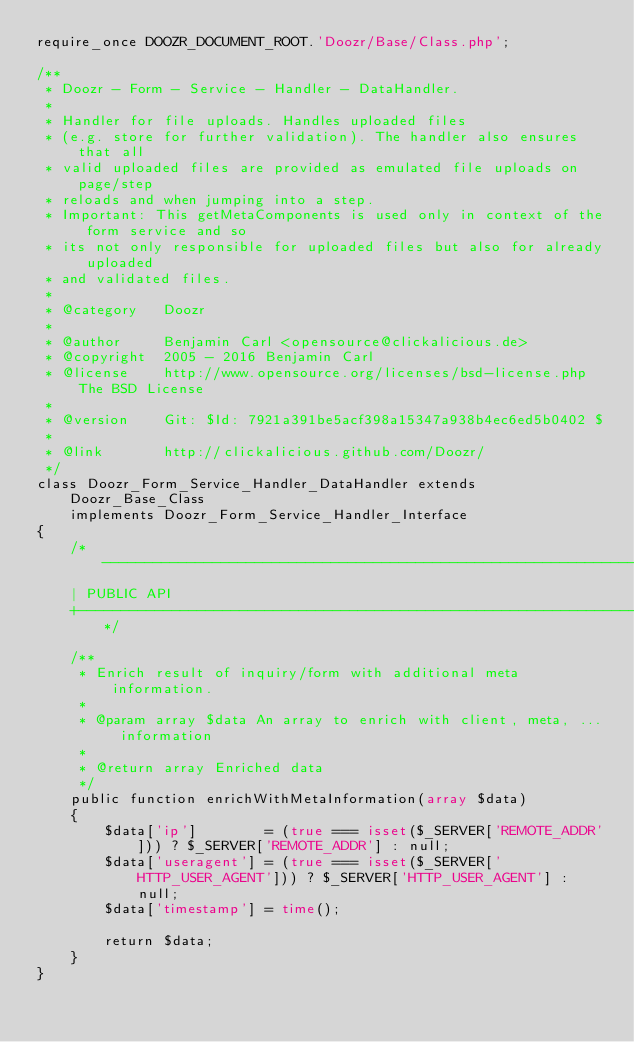Convert code to text. <code><loc_0><loc_0><loc_500><loc_500><_PHP_>require_once DOOZR_DOCUMENT_ROOT.'Doozr/Base/Class.php';

/**
 * Doozr - Form - Service - Handler - DataHandler.
 *
 * Handler for file uploads. Handles uploaded files
 * (e.g. store for further validation). The handler also ensures that all
 * valid uploaded files are provided as emulated file uploads on page/step
 * reloads and when jumping into a step.
 * Important: This getMetaComponents is used only in context of the form service and so
 * its not only responsible for uploaded files but also for already uploaded
 * and validated files.
 *
 * @category   Doozr
 *
 * @author     Benjamin Carl <opensource@clickalicious.de>
 * @copyright  2005 - 2016 Benjamin Carl
 * @license    http://www.opensource.org/licenses/bsd-license.php The BSD License
 *
 * @version    Git: $Id: 7921a391be5acf398a15347a938b4ec6ed5b0402 $
 *
 * @link       http://clickalicious.github.com/Doozr/
 */
class Doozr_Form_Service_Handler_DataHandler extends Doozr_Base_Class
    implements Doozr_Form_Service_Handler_Interface
{
    /*------------------------------------------------------------------------------------------------------------------
    | PUBLIC API
    +-----------------------------------------------------------------------------------------------------------------*/

    /**
     * Enrich result of inquiry/form with additional meta information.
     *
     * @param array $data An array to enrich with client, meta, ... information
     *
     * @return array Enriched data
     */
    public function enrichWithMetaInformation(array $data)
    {
        $data['ip']        = (true === isset($_SERVER['REMOTE_ADDR'])) ? $_SERVER['REMOTE_ADDR'] : null;
        $data['useragent'] = (true === isset($_SERVER['HTTP_USER_AGENT'])) ? $_SERVER['HTTP_USER_AGENT'] : null;
        $data['timestamp'] = time();

        return $data;
    }
}
</code> 